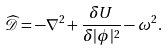<formula> <loc_0><loc_0><loc_500><loc_500>\widehat { \mathcal { D } } = - \nabla ^ { 2 } + \frac { \delta U } { \delta | \phi | ^ { 2 } } - \omega ^ { 2 } .</formula> 